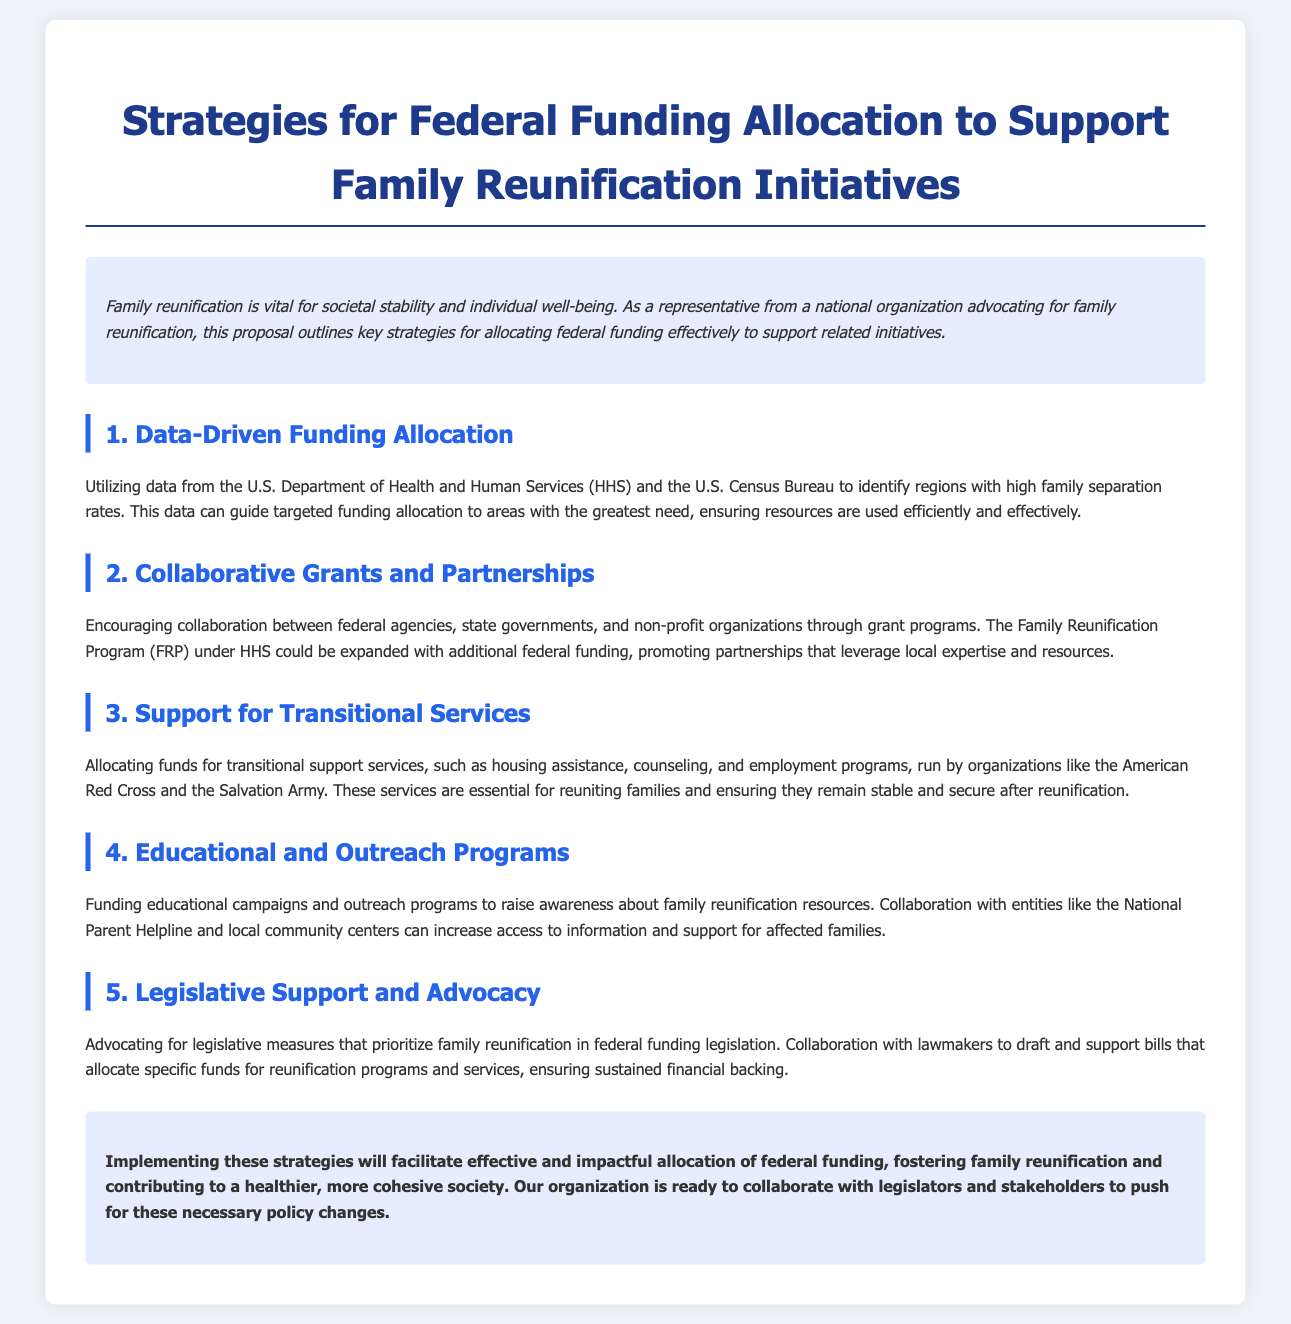What is the title of the proposal? The title is found at the beginning of the document.
Answer: Strategies for Federal Funding Allocation to Support Family Reunification Initiatives What organization is mentioned for providing transitional support services? The document lists specific organizations responsible for transitional support services.
Answer: American Red Cross Which section focuses on data utilization for funding allocation? The section titles indicate the focus areas of the proposal.
Answer: Data-Driven Funding Allocation How many strategies are outlined in the proposal? The number of strategies is indicated in the document's structure.
Answer: Five What does the proposal advocate for in legislative support? The conclusion section summarizes the proposed advocacy efforts.
Answer: Family reunification What program under HHS could be expanded for funding? The relevant program is mentioned in the section about collaborative grants.
Answer: Family Reunification Program (FRP) Which organizations are suggested for collaboration in educational programs? The document specifies organizations for outreach and awareness campaigns.
Answer: National Parent Helpline What is the main goal of the proposed strategies? The conclusion encapsulates the overarching aim of the proposed strategies.
Answer: Family reunification 